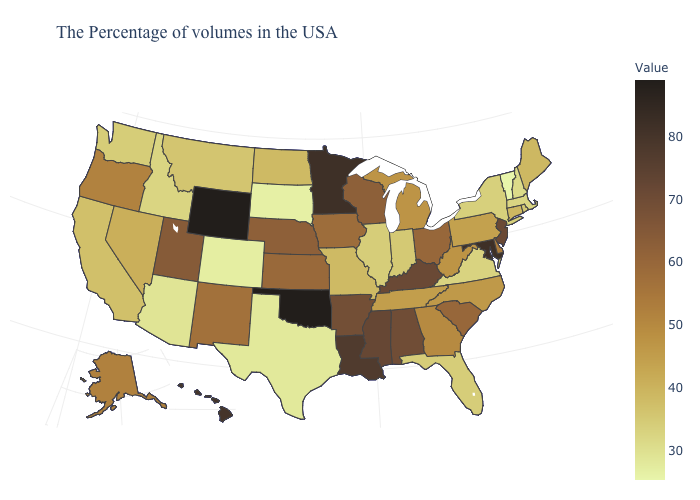Does Minnesota have the highest value in the MidWest?
Keep it brief. Yes. Does Arkansas have the lowest value in the South?
Concise answer only. No. Does Alaska have a higher value than Mississippi?
Answer briefly. No. Does Washington have a higher value than Delaware?
Short answer required. No. Among the states that border Washington , does Idaho have the highest value?
Quick response, please. No. 